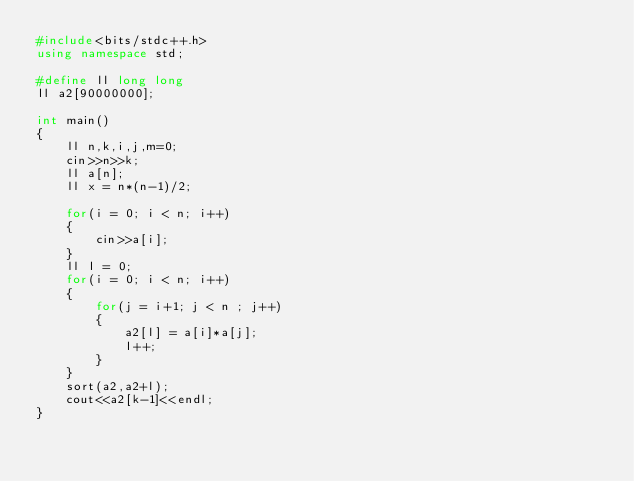<code> <loc_0><loc_0><loc_500><loc_500><_C++_>#include<bits/stdc++.h>
using namespace std;

#define ll long long
ll a2[90000000];

int main()
{
    ll n,k,i,j,m=0;
    cin>>n>>k;
    ll a[n];
    ll x = n*(n-1)/2;

    for(i = 0; i < n; i++)
    {
        cin>>a[i];
    }
    ll l = 0;
    for(i = 0; i < n; i++)
    {
        for(j = i+1; j < n ; j++)
        {
            a2[l] = a[i]*a[j];
            l++;
        }
    }
    sort(a2,a2+l);
    cout<<a2[k-1]<<endl;
}
</code> 